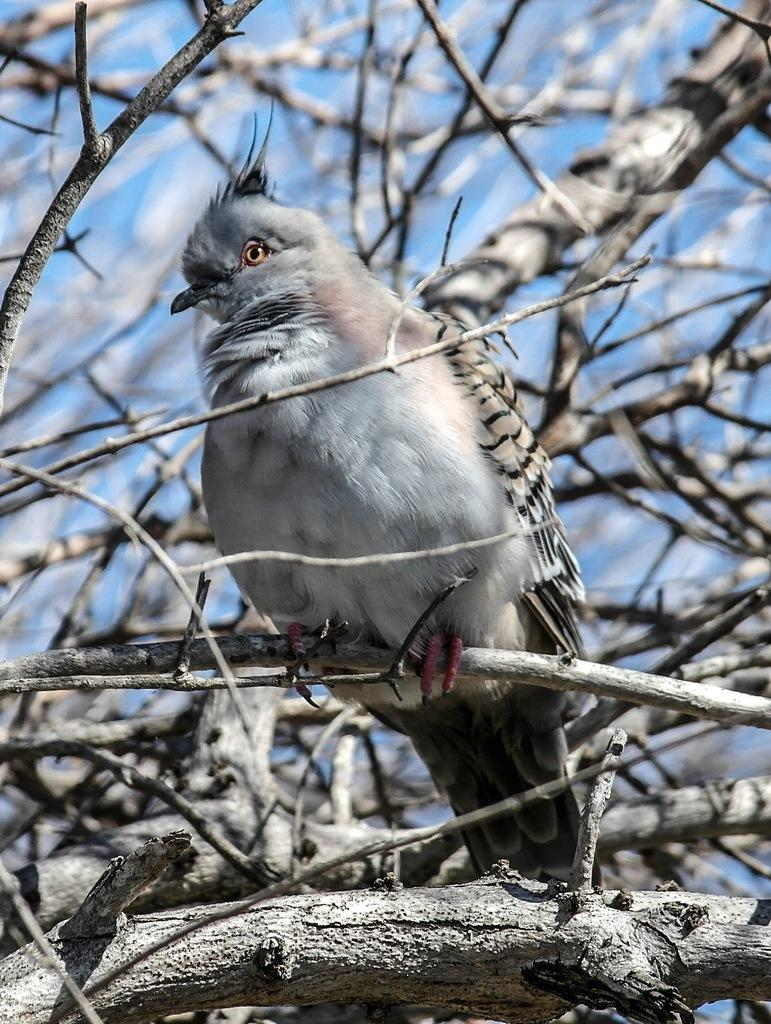What type of animal can be seen in the image? There is a bird in the image. Where is the bird located? The bird is on a tree in the image. What is the tree's location in the image? The tree is in the image. What can be seen behind the tree in the image? The sky is visible behind the tree in the image. What type of class is being held under the tree in the image? There is no class or any indication of a class being held in the image; it only features a bird on a tree. 